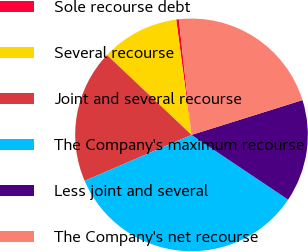Convert chart. <chart><loc_0><loc_0><loc_500><loc_500><pie_chart><fcel>Sole recourse debt<fcel>Several recourse<fcel>Joint and several recourse<fcel>The Company's maximum recourse<fcel>Less joint and several<fcel>The Company's net recourse<nl><fcel>0.37%<fcel>10.85%<fcel>18.51%<fcel>34.14%<fcel>14.23%<fcel>21.89%<nl></chart> 